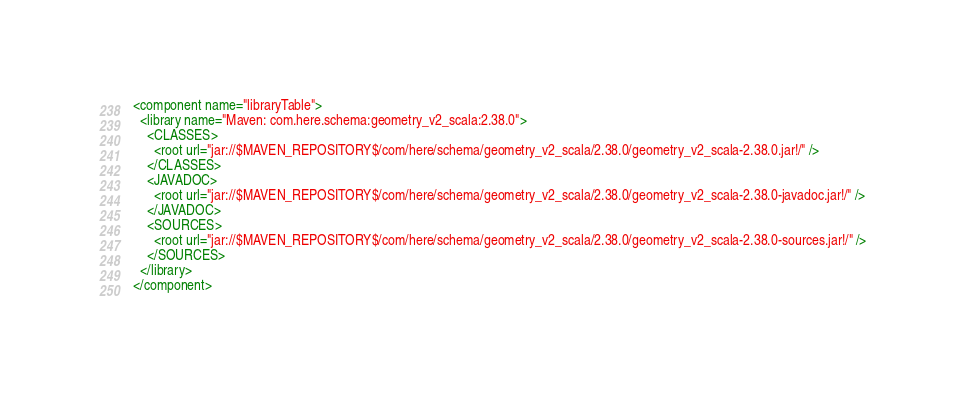Convert code to text. <code><loc_0><loc_0><loc_500><loc_500><_XML_><component name="libraryTable">
  <library name="Maven: com.here.schema:geometry_v2_scala:2.38.0">
    <CLASSES>
      <root url="jar://$MAVEN_REPOSITORY$/com/here/schema/geometry_v2_scala/2.38.0/geometry_v2_scala-2.38.0.jar!/" />
    </CLASSES>
    <JAVADOC>
      <root url="jar://$MAVEN_REPOSITORY$/com/here/schema/geometry_v2_scala/2.38.0/geometry_v2_scala-2.38.0-javadoc.jar!/" />
    </JAVADOC>
    <SOURCES>
      <root url="jar://$MAVEN_REPOSITORY$/com/here/schema/geometry_v2_scala/2.38.0/geometry_v2_scala-2.38.0-sources.jar!/" />
    </SOURCES>
  </library>
</component></code> 